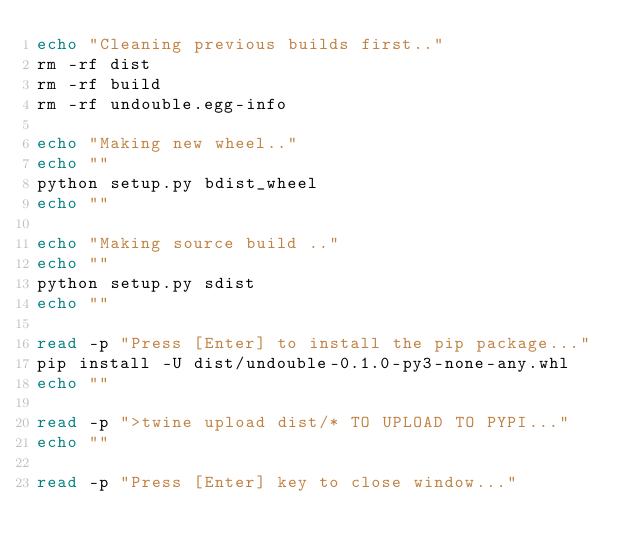<code> <loc_0><loc_0><loc_500><loc_500><_Bash_>echo "Cleaning previous builds first.."
rm -rf dist
rm -rf build
rm -rf undouble.egg-info

echo "Making new wheel.."
echo ""
python setup.py bdist_wheel
echo ""

echo "Making source build .."
echo ""
python setup.py sdist
echo ""

read -p "Press [Enter] to install the pip package..."
pip install -U dist/undouble-0.1.0-py3-none-any.whl
echo ""

read -p ">twine upload dist/* TO UPLOAD TO PYPI..."
echo ""

read -p "Press [Enter] key to close window..."
</code> 